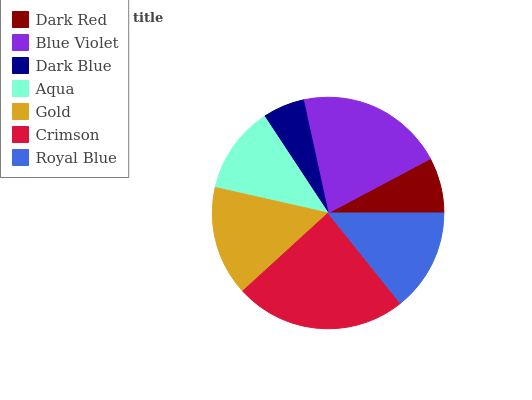Is Dark Blue the minimum?
Answer yes or no. Yes. Is Crimson the maximum?
Answer yes or no. Yes. Is Blue Violet the minimum?
Answer yes or no. No. Is Blue Violet the maximum?
Answer yes or no. No. Is Blue Violet greater than Dark Red?
Answer yes or no. Yes. Is Dark Red less than Blue Violet?
Answer yes or no. Yes. Is Dark Red greater than Blue Violet?
Answer yes or no. No. Is Blue Violet less than Dark Red?
Answer yes or no. No. Is Royal Blue the high median?
Answer yes or no. Yes. Is Royal Blue the low median?
Answer yes or no. Yes. Is Dark Red the high median?
Answer yes or no. No. Is Blue Violet the low median?
Answer yes or no. No. 